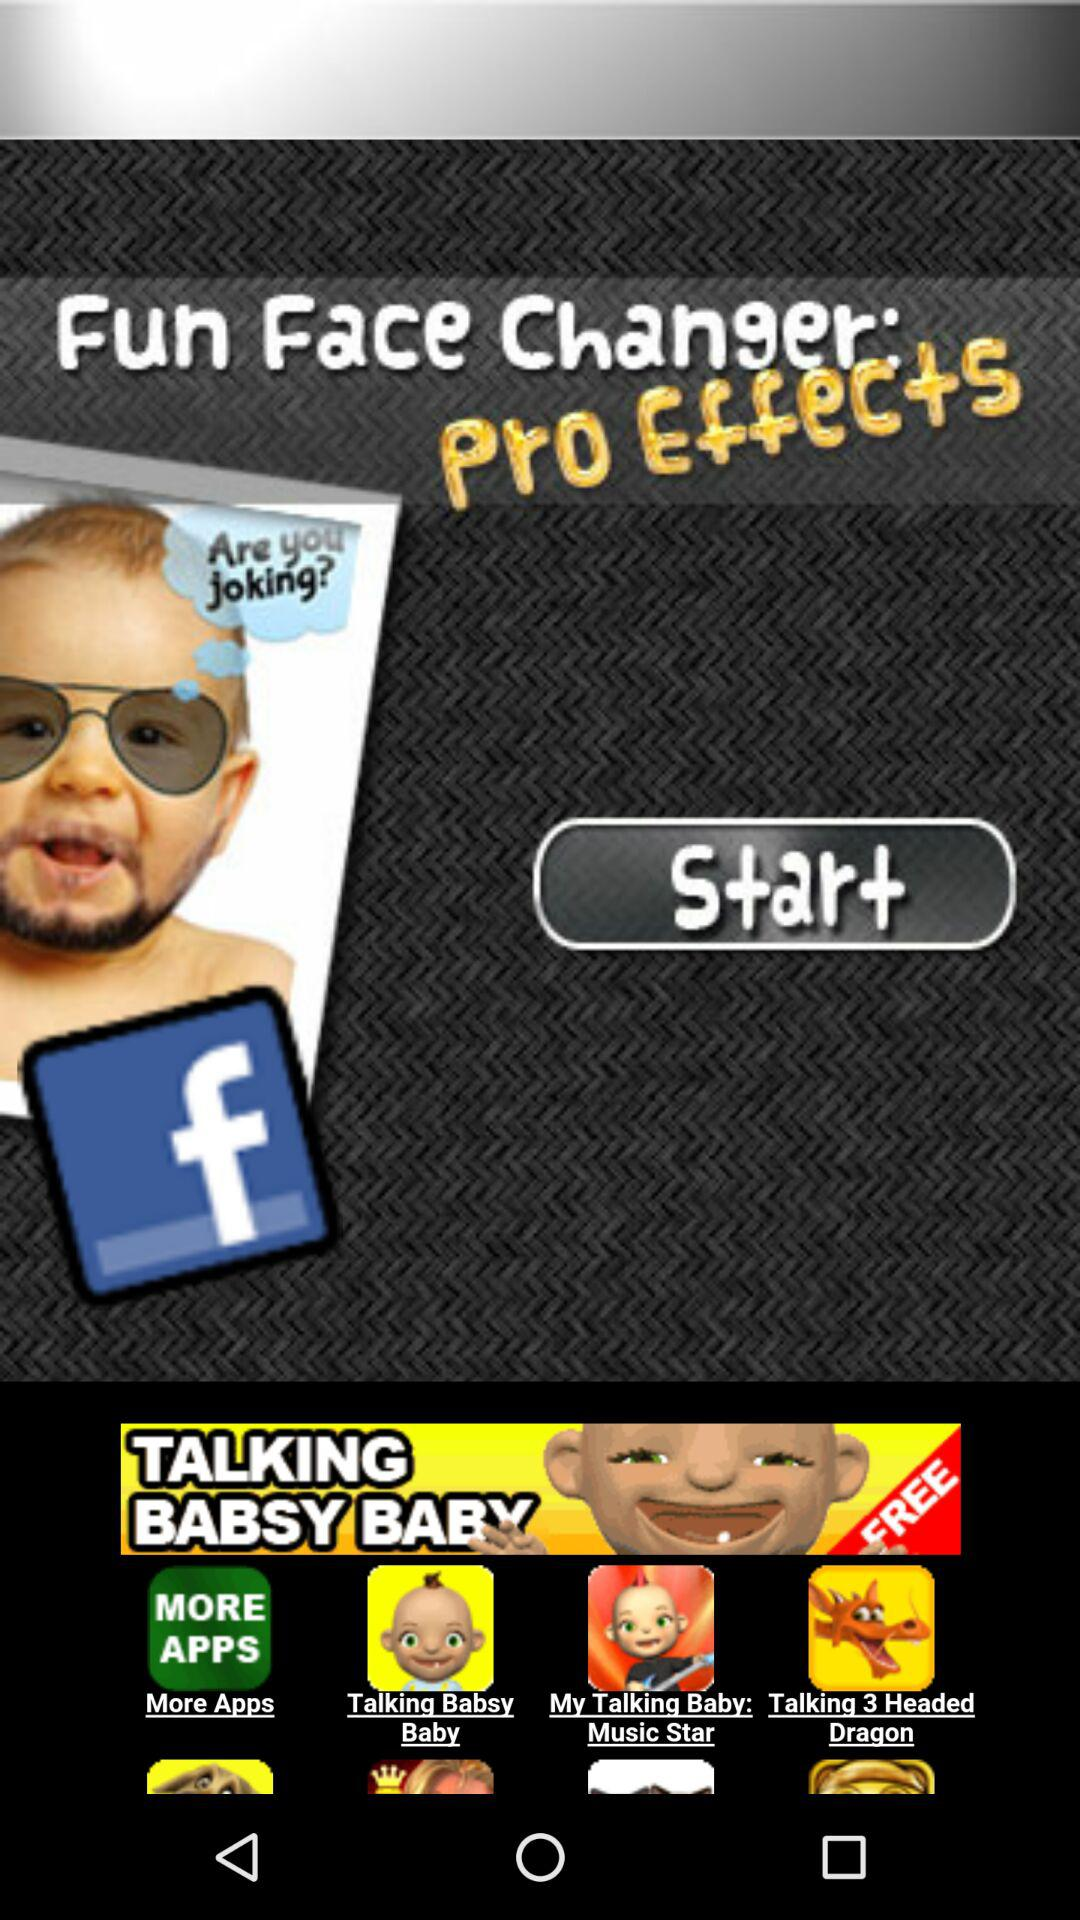What is the name of the application? The names of the applications are "Fun Face Changer: Pro Effects", "Talking Babsy Baby", "My Talking Baby: Music Star" and "Talking 3 Headed Dragon". 